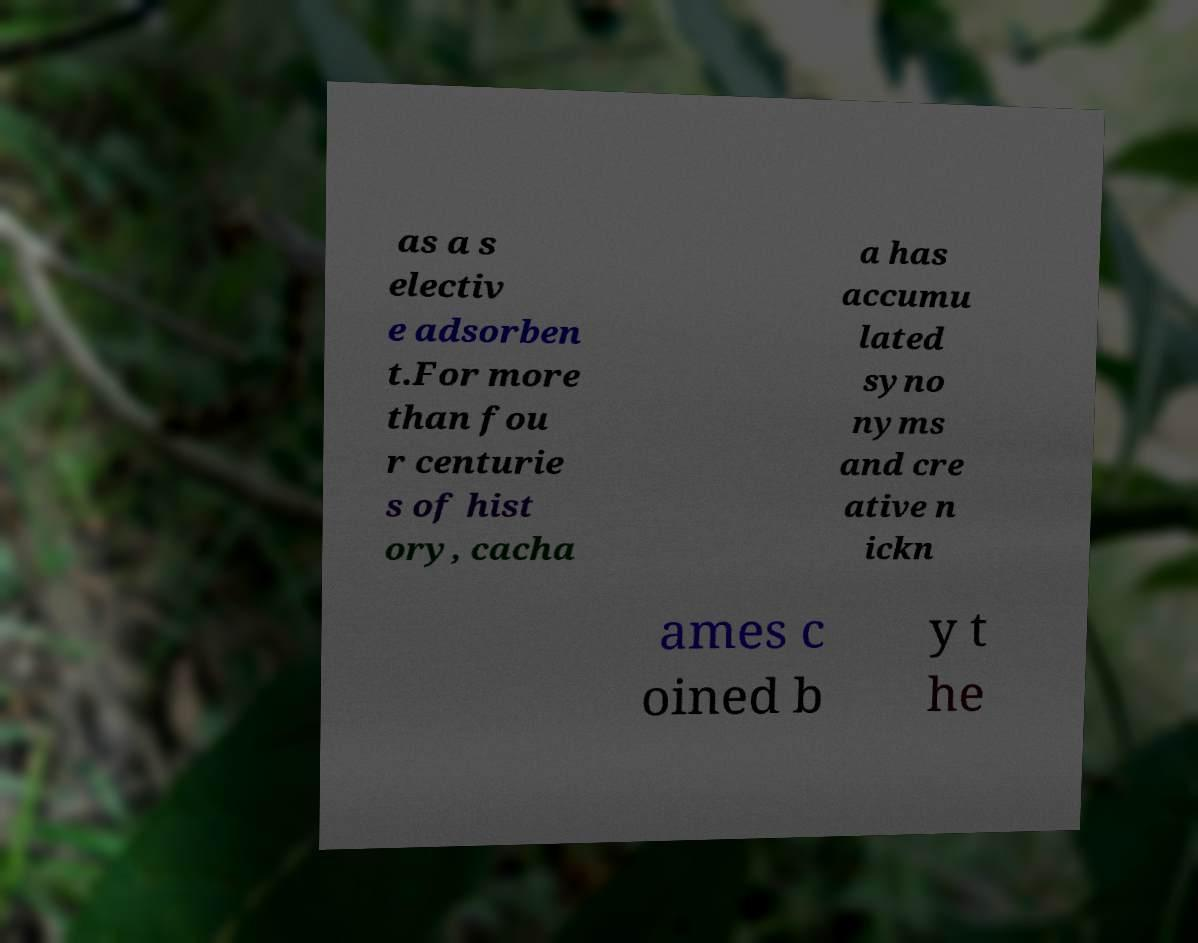For documentation purposes, I need the text within this image transcribed. Could you provide that? as a s electiv e adsorben t.For more than fou r centurie s of hist ory, cacha a has accumu lated syno nyms and cre ative n ickn ames c oined b y t he 